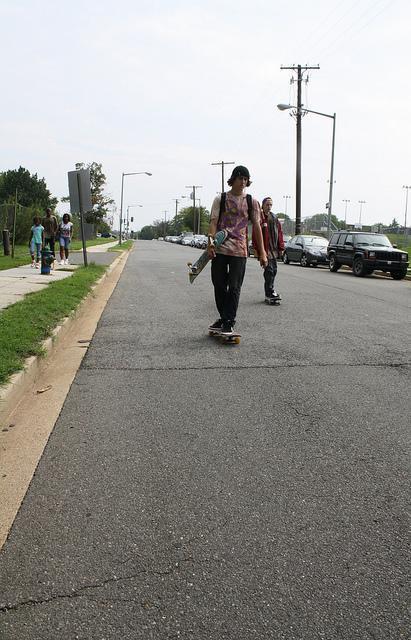How many skateboards are there?
Give a very brief answer. 3. 